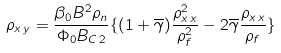Convert formula to latex. <formula><loc_0><loc_0><loc_500><loc_500>\rho _ { x \, y } = \frac { \beta _ { 0 } B ^ { 2 } \rho _ { n } } { \Phi _ { 0 } B _ { C \, 2 } } \{ ( 1 + \overline { \gamma } ) \frac { \rho _ { x \, x } ^ { 2 } } { \rho _ { f } ^ { 2 } } - 2 \overline { \gamma } \frac { \rho _ { x \, x } } { \rho _ { f } } \}</formula> 